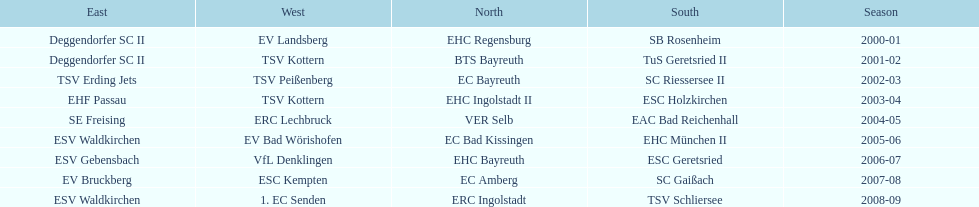Could you help me parse every detail presented in this table? {'header': ['East', 'West', 'North', 'South', 'Season'], 'rows': [['Deggendorfer SC II', 'EV Landsberg', 'EHC Regensburg', 'SB Rosenheim', '2000-01'], ['Deggendorfer SC II', 'TSV Kottern', 'BTS Bayreuth', 'TuS Geretsried II', '2001-02'], ['TSV Erding Jets', 'TSV Peißenberg', 'EC Bayreuth', 'SC Riessersee II', '2002-03'], ['EHF Passau', 'TSV Kottern', 'EHC Ingolstadt II', 'ESC Holzkirchen', '2003-04'], ['SE Freising', 'ERC Lechbruck', 'VER Selb', 'EAC Bad Reichenhall', '2004-05'], ['ESV Waldkirchen', 'EV Bad Wörishofen', 'EC Bad Kissingen', 'EHC München II', '2005-06'], ['ESV Gebensbach', 'VfL Denklingen', 'EHC Bayreuth', 'ESC Geretsried', '2006-07'], ['EV Bruckberg', 'ESC Kempten', 'EC Amberg', 'SC Gaißach', '2007-08'], ['ESV Waldkirchen', '1. EC Senden', 'ERC Ingolstadt', 'TSV Schliersee', '2008-09']]} The last team to win the west? 1. EC Senden. 